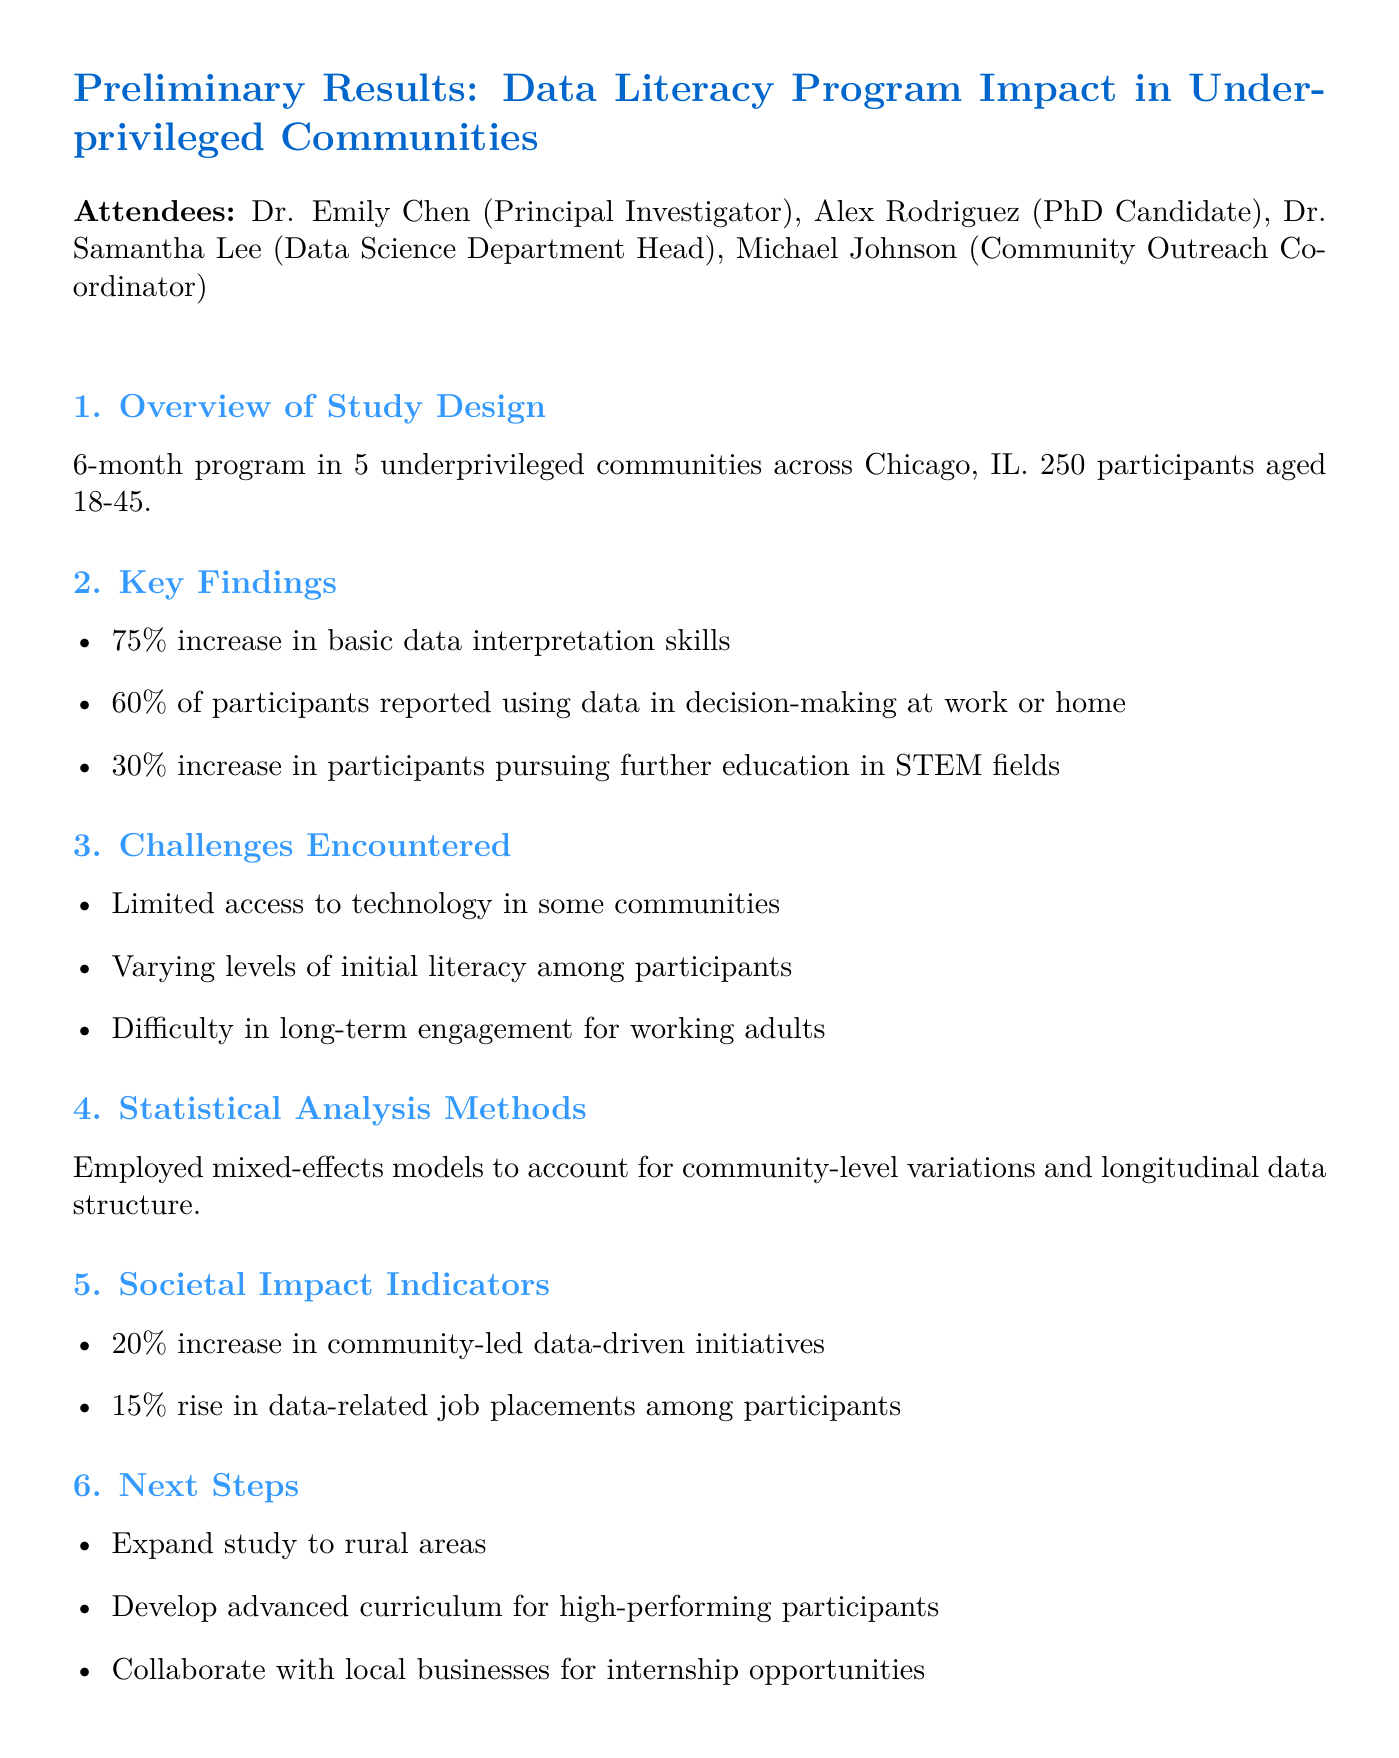What is the date of the meeting? The date of the meeting is explicitly mentioned in the document as "2023-05-15."
Answer: 2023-05-15 How many participants were involved in the study? The document states that there were "250 participants aged 18-45" in the study.
Answer: 250 participants What was the percentage increase in basic data interpretation skills? The key finding indicates a "75% increase in basic data interpretation skills."
Answer: 75% What challenges were encountered in the study? The document lists challenges, including "Limited access to technology in some communities."
Answer: Limited access to technology What statistical analysis method was employed? The document specifies that "mixed-effects models" were used for analysis.
Answer: mixed-effects models What is one of the next steps proposed in the meeting? The document states a next step to "Expand study to rural areas."
Answer: Expand study to rural areas Which attendee is the Principal Investigator? The document lists "Dr. Emily Chen" as the Principal Investigator.
Answer: Dr. Emily Chen What was the reported increase in community-led data-driven initiatives? The summary of societal impact indicators shows a "20% increase in community-led data-driven initiatives."
Answer: 20% How many action items were outlined in the meeting? There are three action items listed in the document.
Answer: 3 